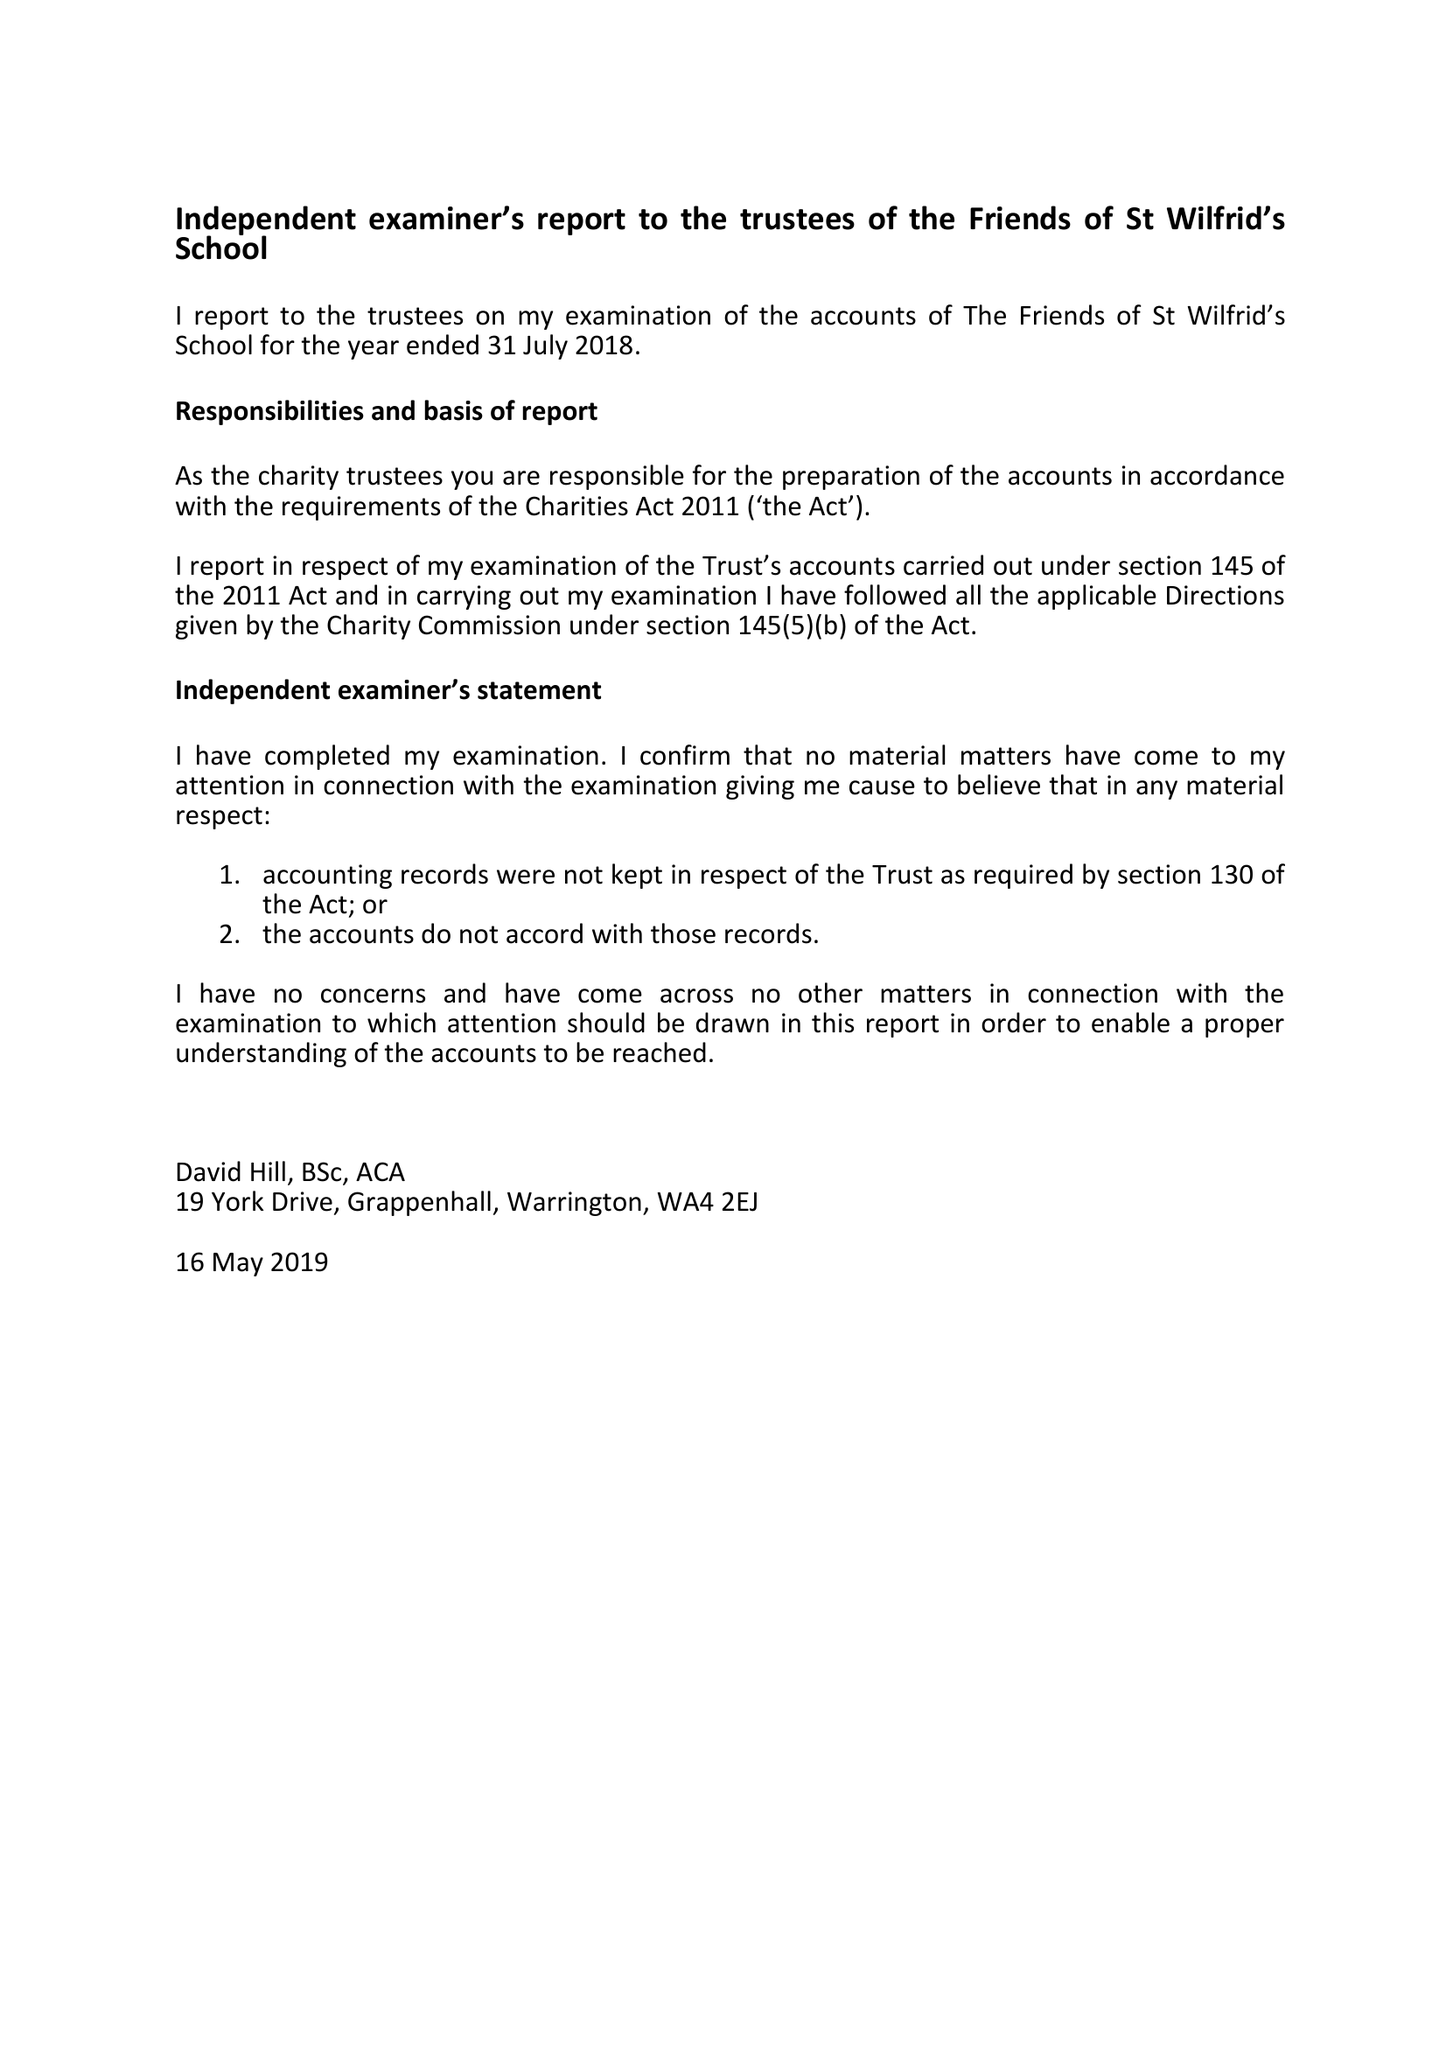What is the value for the address__street_line?
Answer the question using a single word or phrase. 36 MARTHAM CLOSE 